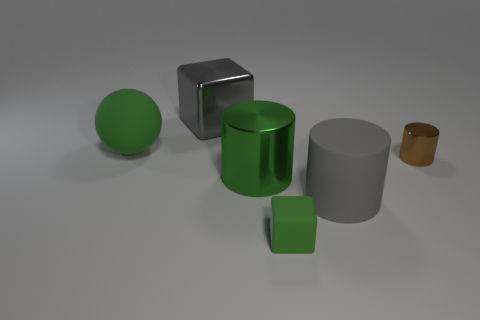Are there fewer big blue rubber spheres than gray shiny cubes?
Ensure brevity in your answer.  Yes. What number of large things are either green cubes or green spheres?
Make the answer very short. 1. What number of matte things are behind the small cylinder and in front of the gray rubber thing?
Provide a succinct answer. 0. Is the number of large purple cubes greater than the number of rubber spheres?
Offer a very short reply. No. What number of other things are the same shape as the brown shiny object?
Your response must be concise. 2. Does the large shiny cube have the same color as the tiny block?
Provide a short and direct response. No. What material is the cylinder that is both behind the large gray rubber thing and to the right of the green rubber block?
Your answer should be very brief. Metal. The green cylinder is what size?
Offer a very short reply. Large. How many shiny cylinders are to the left of the gray object on the right side of the gray metal object on the left side of the small brown object?
Give a very brief answer. 1. What is the shape of the small thing that is to the right of the large cylinder in front of the big green shiny thing?
Provide a short and direct response. Cylinder. 